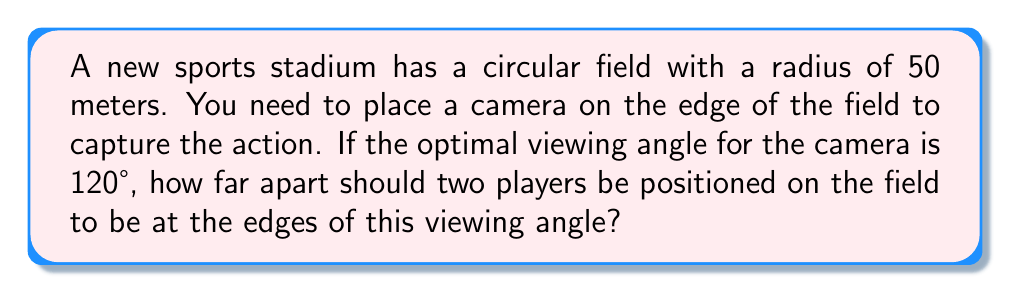Can you solve this math problem? Let's approach this step-by-step:

1) In a circle, the angle at the center is twice the angle at the circumference when both angles intercept the same arc. So, if the viewing angle at the camera (on the circumference) is 120°, the corresponding central angle is 240°.

2) The central angle in radians is given by the formula:
   $$\theta = \frac{s}{r}$$
   where $\theta$ is the angle in radians, $s$ is the arc length, and $r$ is the radius.

3) We need to convert 240° to radians:
   $$240° = 240 \cdot \frac{\pi}{180} = \frac{4\pi}{3} \text{ radians}$$

4) Now we can use the formula to find the arc length:
   $$\frac{4\pi}{3} = \frac{s}{50}$$

5) Solving for $s$:
   $$s = 50 \cdot \frac{4\pi}{3} = \frac{200\pi}{3} \approx 209.44 \text{ meters}$$

6) This arc length represents the distance between the two players along the circumference of the field.

7) To find the straight-line distance between the players, we can use the chord formula:
   $$c = 2r \sin(\frac{\theta}{2})$$
   where $c$ is the chord length, $r$ is the radius, and $\theta$ is the central angle in radians.

8) Plugging in our values:
   $$c = 2 \cdot 50 \cdot \sin(\frac{4\pi}{6}) = 100 \cdot \sin(\frac{2\pi}{3}) = 100 \cdot \frac{\sqrt{3}}{2} = 50\sqrt{3} \approx 86.60 \text{ meters}$$

Therefore, the players should be positioned approximately 86.60 meters apart to be at the edges of the 120° viewing angle.
Answer: $50\sqrt{3}$ meters 